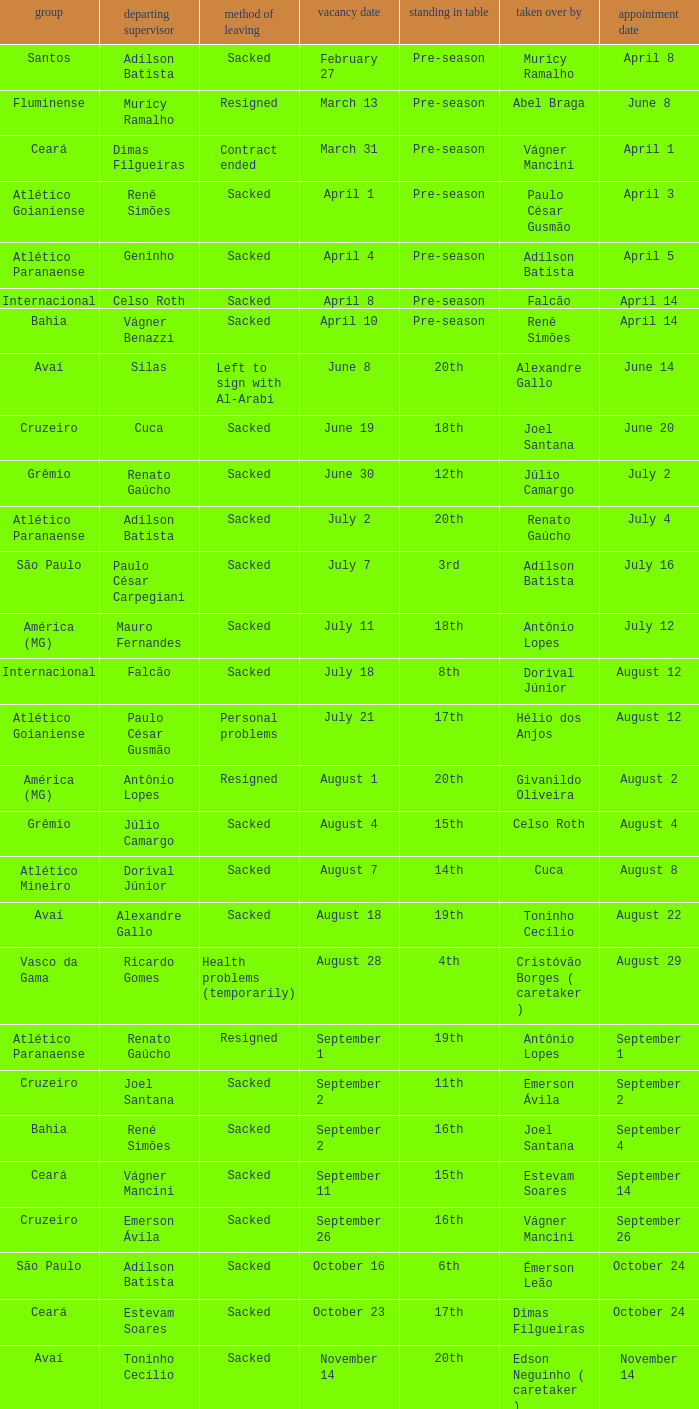Why did Geninho leave as manager? Sacked. 